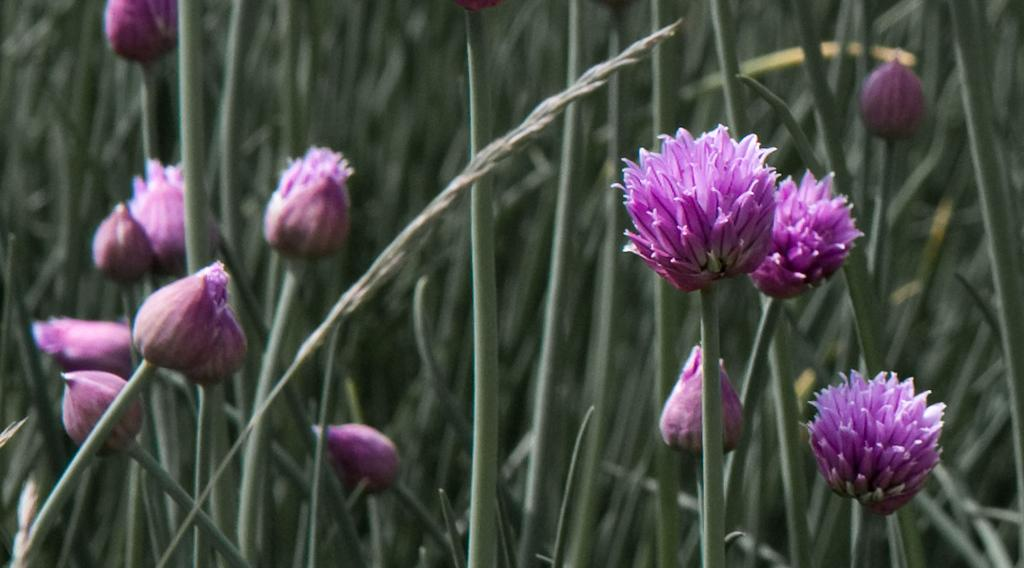What type of plants can be seen in the image? There are flowers in the image. What stage of growth are the plants in? There are buds on the plants in the image. What type of wire is used to support the flowers in the image? There is no wire visible in the image; the flowers are not supported by any visible structure. 